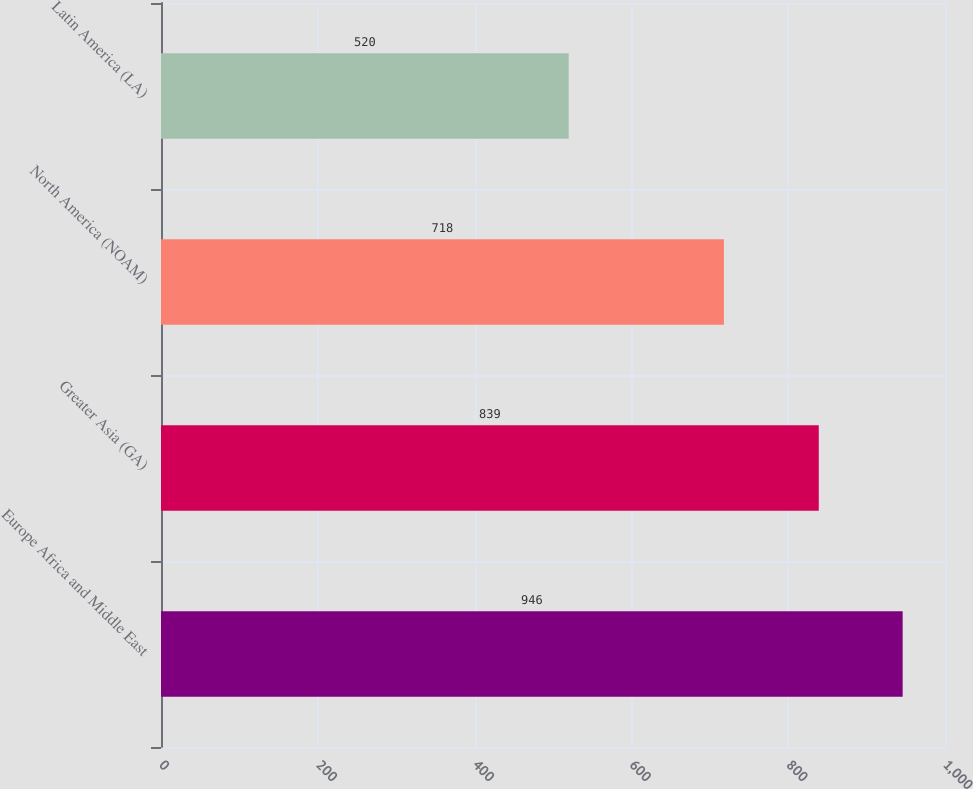<chart> <loc_0><loc_0><loc_500><loc_500><bar_chart><fcel>Europe Africa and Middle East<fcel>Greater Asia (GA)<fcel>North America (NOAM)<fcel>Latin America (LA)<nl><fcel>946<fcel>839<fcel>718<fcel>520<nl></chart> 